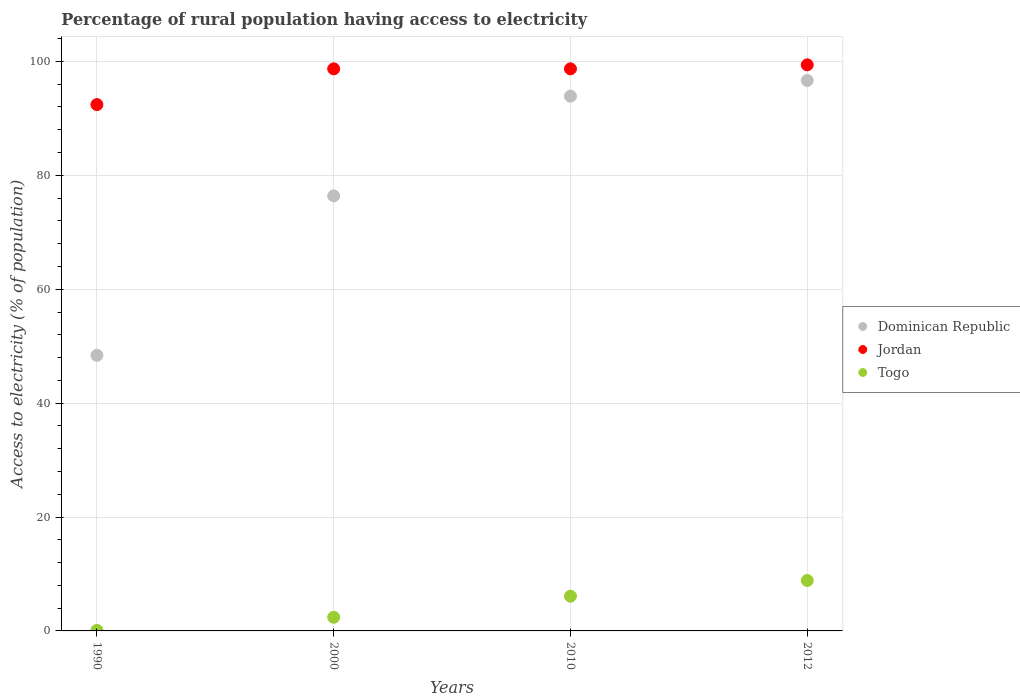What is the percentage of rural population having access to electricity in Dominican Republic in 2012?
Make the answer very short. 96.65. Across all years, what is the maximum percentage of rural population having access to electricity in Dominican Republic?
Ensure brevity in your answer.  96.65. Across all years, what is the minimum percentage of rural population having access to electricity in Togo?
Make the answer very short. 0.1. In which year was the percentage of rural population having access to electricity in Jordan maximum?
Your answer should be compact. 2012. In which year was the percentage of rural population having access to electricity in Jordan minimum?
Make the answer very short. 1990. What is the total percentage of rural population having access to electricity in Dominican Republic in the graph?
Offer a very short reply. 315.35. What is the difference between the percentage of rural population having access to electricity in Togo in 2000 and the percentage of rural population having access to electricity in Dominican Republic in 2012?
Your answer should be very brief. -94.25. What is the average percentage of rural population having access to electricity in Togo per year?
Provide a succinct answer. 4.36. In the year 2012, what is the difference between the percentage of rural population having access to electricity in Togo and percentage of rural population having access to electricity in Dominican Republic?
Provide a short and direct response. -87.8. What is the ratio of the percentage of rural population having access to electricity in Jordan in 1990 to that in 2000?
Ensure brevity in your answer.  0.94. Is the percentage of rural population having access to electricity in Dominican Republic in 2000 less than that in 2010?
Provide a succinct answer. Yes. What is the difference between the highest and the second highest percentage of rural population having access to electricity in Jordan?
Your response must be concise. 0.7. What is the difference between the highest and the lowest percentage of rural population having access to electricity in Togo?
Give a very brief answer. 8.75. In how many years, is the percentage of rural population having access to electricity in Dominican Republic greater than the average percentage of rural population having access to electricity in Dominican Republic taken over all years?
Provide a succinct answer. 2. Is the sum of the percentage of rural population having access to electricity in Togo in 1990 and 2012 greater than the maximum percentage of rural population having access to electricity in Jordan across all years?
Keep it short and to the point. No. Is it the case that in every year, the sum of the percentage of rural population having access to electricity in Togo and percentage of rural population having access to electricity in Dominican Republic  is greater than the percentage of rural population having access to electricity in Jordan?
Give a very brief answer. No. Is the percentage of rural population having access to electricity in Dominican Republic strictly less than the percentage of rural population having access to electricity in Togo over the years?
Provide a succinct answer. No. What is the difference between two consecutive major ticks on the Y-axis?
Offer a terse response. 20. Are the values on the major ticks of Y-axis written in scientific E-notation?
Your answer should be very brief. No. Does the graph contain any zero values?
Offer a terse response. No. Where does the legend appear in the graph?
Offer a very short reply. Center right. What is the title of the graph?
Provide a short and direct response. Percentage of rural population having access to electricity. What is the label or title of the X-axis?
Give a very brief answer. Years. What is the label or title of the Y-axis?
Offer a very short reply. Access to electricity (% of population). What is the Access to electricity (% of population) of Dominican Republic in 1990?
Give a very brief answer. 48.4. What is the Access to electricity (% of population) in Jordan in 1990?
Provide a succinct answer. 92.42. What is the Access to electricity (% of population) in Dominican Republic in 2000?
Offer a terse response. 76.4. What is the Access to electricity (% of population) in Jordan in 2000?
Provide a succinct answer. 98.7. What is the Access to electricity (% of population) in Togo in 2000?
Give a very brief answer. 2.4. What is the Access to electricity (% of population) of Dominican Republic in 2010?
Make the answer very short. 93.9. What is the Access to electricity (% of population) in Jordan in 2010?
Ensure brevity in your answer.  98.7. What is the Access to electricity (% of population) in Togo in 2010?
Your answer should be very brief. 6.1. What is the Access to electricity (% of population) of Dominican Republic in 2012?
Your answer should be very brief. 96.65. What is the Access to electricity (% of population) of Jordan in 2012?
Keep it short and to the point. 99.4. What is the Access to electricity (% of population) in Togo in 2012?
Your answer should be very brief. 8.85. Across all years, what is the maximum Access to electricity (% of population) in Dominican Republic?
Provide a short and direct response. 96.65. Across all years, what is the maximum Access to electricity (% of population) of Jordan?
Offer a very short reply. 99.4. Across all years, what is the maximum Access to electricity (% of population) in Togo?
Your answer should be compact. 8.85. Across all years, what is the minimum Access to electricity (% of population) in Dominican Republic?
Make the answer very short. 48.4. Across all years, what is the minimum Access to electricity (% of population) of Jordan?
Offer a terse response. 92.42. Across all years, what is the minimum Access to electricity (% of population) in Togo?
Your response must be concise. 0.1. What is the total Access to electricity (% of population) in Dominican Republic in the graph?
Offer a terse response. 315.35. What is the total Access to electricity (% of population) in Jordan in the graph?
Offer a terse response. 389.22. What is the total Access to electricity (% of population) in Togo in the graph?
Keep it short and to the point. 17.45. What is the difference between the Access to electricity (% of population) in Dominican Republic in 1990 and that in 2000?
Make the answer very short. -28. What is the difference between the Access to electricity (% of population) in Jordan in 1990 and that in 2000?
Provide a short and direct response. -6.28. What is the difference between the Access to electricity (% of population) in Togo in 1990 and that in 2000?
Offer a very short reply. -2.3. What is the difference between the Access to electricity (% of population) in Dominican Republic in 1990 and that in 2010?
Offer a terse response. -45.5. What is the difference between the Access to electricity (% of population) of Jordan in 1990 and that in 2010?
Your answer should be compact. -6.28. What is the difference between the Access to electricity (% of population) in Dominican Republic in 1990 and that in 2012?
Provide a short and direct response. -48.25. What is the difference between the Access to electricity (% of population) in Jordan in 1990 and that in 2012?
Offer a very short reply. -6.98. What is the difference between the Access to electricity (% of population) in Togo in 1990 and that in 2012?
Keep it short and to the point. -8.75. What is the difference between the Access to electricity (% of population) in Dominican Republic in 2000 and that in 2010?
Make the answer very short. -17.5. What is the difference between the Access to electricity (% of population) in Jordan in 2000 and that in 2010?
Give a very brief answer. 0. What is the difference between the Access to electricity (% of population) in Dominican Republic in 2000 and that in 2012?
Give a very brief answer. -20.25. What is the difference between the Access to electricity (% of population) in Jordan in 2000 and that in 2012?
Make the answer very short. -0.7. What is the difference between the Access to electricity (% of population) in Togo in 2000 and that in 2012?
Offer a terse response. -6.45. What is the difference between the Access to electricity (% of population) of Dominican Republic in 2010 and that in 2012?
Make the answer very short. -2.75. What is the difference between the Access to electricity (% of population) in Togo in 2010 and that in 2012?
Your answer should be compact. -2.75. What is the difference between the Access to electricity (% of population) in Dominican Republic in 1990 and the Access to electricity (% of population) in Jordan in 2000?
Provide a short and direct response. -50.3. What is the difference between the Access to electricity (% of population) in Jordan in 1990 and the Access to electricity (% of population) in Togo in 2000?
Your response must be concise. 90.02. What is the difference between the Access to electricity (% of population) in Dominican Republic in 1990 and the Access to electricity (% of population) in Jordan in 2010?
Keep it short and to the point. -50.3. What is the difference between the Access to electricity (% of population) of Dominican Republic in 1990 and the Access to electricity (% of population) of Togo in 2010?
Offer a terse response. 42.3. What is the difference between the Access to electricity (% of population) in Jordan in 1990 and the Access to electricity (% of population) in Togo in 2010?
Offer a very short reply. 86.32. What is the difference between the Access to electricity (% of population) of Dominican Republic in 1990 and the Access to electricity (% of population) of Jordan in 2012?
Your answer should be very brief. -51. What is the difference between the Access to electricity (% of population) of Dominican Republic in 1990 and the Access to electricity (% of population) of Togo in 2012?
Make the answer very short. 39.55. What is the difference between the Access to electricity (% of population) of Jordan in 1990 and the Access to electricity (% of population) of Togo in 2012?
Give a very brief answer. 83.57. What is the difference between the Access to electricity (% of population) of Dominican Republic in 2000 and the Access to electricity (% of population) of Jordan in 2010?
Ensure brevity in your answer.  -22.3. What is the difference between the Access to electricity (% of population) of Dominican Republic in 2000 and the Access to electricity (% of population) of Togo in 2010?
Provide a short and direct response. 70.3. What is the difference between the Access to electricity (% of population) in Jordan in 2000 and the Access to electricity (% of population) in Togo in 2010?
Your answer should be compact. 92.6. What is the difference between the Access to electricity (% of population) of Dominican Republic in 2000 and the Access to electricity (% of population) of Togo in 2012?
Give a very brief answer. 67.55. What is the difference between the Access to electricity (% of population) of Jordan in 2000 and the Access to electricity (% of population) of Togo in 2012?
Give a very brief answer. 89.85. What is the difference between the Access to electricity (% of population) in Dominican Republic in 2010 and the Access to electricity (% of population) in Togo in 2012?
Offer a very short reply. 85.05. What is the difference between the Access to electricity (% of population) in Jordan in 2010 and the Access to electricity (% of population) in Togo in 2012?
Ensure brevity in your answer.  89.85. What is the average Access to electricity (% of population) of Dominican Republic per year?
Provide a short and direct response. 78.84. What is the average Access to electricity (% of population) of Jordan per year?
Keep it short and to the point. 97.3. What is the average Access to electricity (% of population) of Togo per year?
Your answer should be compact. 4.36. In the year 1990, what is the difference between the Access to electricity (% of population) of Dominican Republic and Access to electricity (% of population) of Jordan?
Make the answer very short. -44.02. In the year 1990, what is the difference between the Access to electricity (% of population) of Dominican Republic and Access to electricity (% of population) of Togo?
Offer a very short reply. 48.3. In the year 1990, what is the difference between the Access to electricity (% of population) in Jordan and Access to electricity (% of population) in Togo?
Keep it short and to the point. 92.32. In the year 2000, what is the difference between the Access to electricity (% of population) in Dominican Republic and Access to electricity (% of population) in Jordan?
Provide a short and direct response. -22.3. In the year 2000, what is the difference between the Access to electricity (% of population) of Dominican Republic and Access to electricity (% of population) of Togo?
Your response must be concise. 74. In the year 2000, what is the difference between the Access to electricity (% of population) in Jordan and Access to electricity (% of population) in Togo?
Give a very brief answer. 96.3. In the year 2010, what is the difference between the Access to electricity (% of population) in Dominican Republic and Access to electricity (% of population) in Jordan?
Make the answer very short. -4.8. In the year 2010, what is the difference between the Access to electricity (% of population) of Dominican Republic and Access to electricity (% of population) of Togo?
Your answer should be very brief. 87.8. In the year 2010, what is the difference between the Access to electricity (% of population) in Jordan and Access to electricity (% of population) in Togo?
Keep it short and to the point. 92.6. In the year 2012, what is the difference between the Access to electricity (% of population) of Dominican Republic and Access to electricity (% of population) of Jordan?
Offer a very short reply. -2.75. In the year 2012, what is the difference between the Access to electricity (% of population) of Dominican Republic and Access to electricity (% of population) of Togo?
Provide a short and direct response. 87.8. In the year 2012, what is the difference between the Access to electricity (% of population) of Jordan and Access to electricity (% of population) of Togo?
Offer a terse response. 90.55. What is the ratio of the Access to electricity (% of population) of Dominican Republic in 1990 to that in 2000?
Your answer should be compact. 0.63. What is the ratio of the Access to electricity (% of population) of Jordan in 1990 to that in 2000?
Offer a very short reply. 0.94. What is the ratio of the Access to electricity (% of population) in Togo in 1990 to that in 2000?
Your answer should be compact. 0.04. What is the ratio of the Access to electricity (% of population) of Dominican Republic in 1990 to that in 2010?
Ensure brevity in your answer.  0.52. What is the ratio of the Access to electricity (% of population) in Jordan in 1990 to that in 2010?
Give a very brief answer. 0.94. What is the ratio of the Access to electricity (% of population) in Togo in 1990 to that in 2010?
Give a very brief answer. 0.02. What is the ratio of the Access to electricity (% of population) in Dominican Republic in 1990 to that in 2012?
Give a very brief answer. 0.5. What is the ratio of the Access to electricity (% of population) of Jordan in 1990 to that in 2012?
Provide a succinct answer. 0.93. What is the ratio of the Access to electricity (% of population) in Togo in 1990 to that in 2012?
Your answer should be very brief. 0.01. What is the ratio of the Access to electricity (% of population) in Dominican Republic in 2000 to that in 2010?
Provide a short and direct response. 0.81. What is the ratio of the Access to electricity (% of population) of Jordan in 2000 to that in 2010?
Your answer should be very brief. 1. What is the ratio of the Access to electricity (% of population) of Togo in 2000 to that in 2010?
Keep it short and to the point. 0.39. What is the ratio of the Access to electricity (% of population) in Dominican Republic in 2000 to that in 2012?
Keep it short and to the point. 0.79. What is the ratio of the Access to electricity (% of population) of Togo in 2000 to that in 2012?
Offer a terse response. 0.27. What is the ratio of the Access to electricity (% of population) in Dominican Republic in 2010 to that in 2012?
Offer a terse response. 0.97. What is the ratio of the Access to electricity (% of population) of Togo in 2010 to that in 2012?
Offer a terse response. 0.69. What is the difference between the highest and the second highest Access to electricity (% of population) of Dominican Republic?
Your answer should be very brief. 2.75. What is the difference between the highest and the second highest Access to electricity (% of population) of Jordan?
Your answer should be very brief. 0.7. What is the difference between the highest and the second highest Access to electricity (% of population) of Togo?
Provide a short and direct response. 2.75. What is the difference between the highest and the lowest Access to electricity (% of population) of Dominican Republic?
Provide a succinct answer. 48.25. What is the difference between the highest and the lowest Access to electricity (% of population) in Jordan?
Give a very brief answer. 6.98. What is the difference between the highest and the lowest Access to electricity (% of population) of Togo?
Provide a short and direct response. 8.75. 